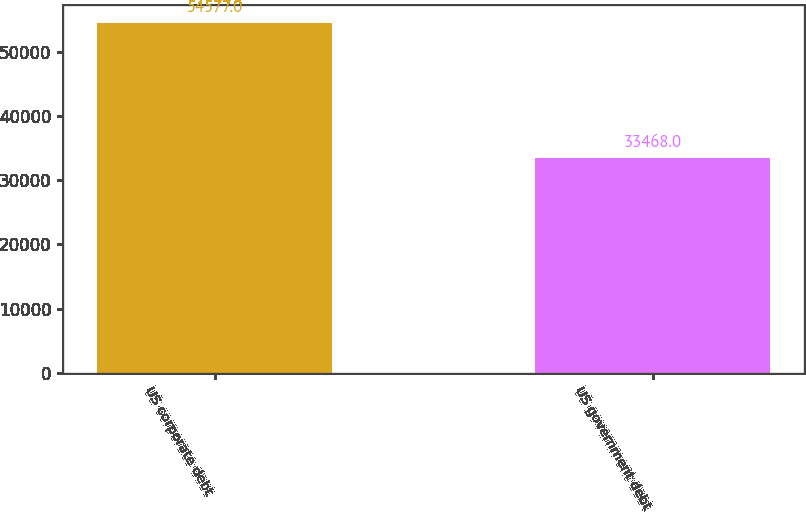<chart> <loc_0><loc_0><loc_500><loc_500><bar_chart><fcel>US corporate debt<fcel>US government debt<nl><fcel>54577<fcel>33468<nl></chart> 